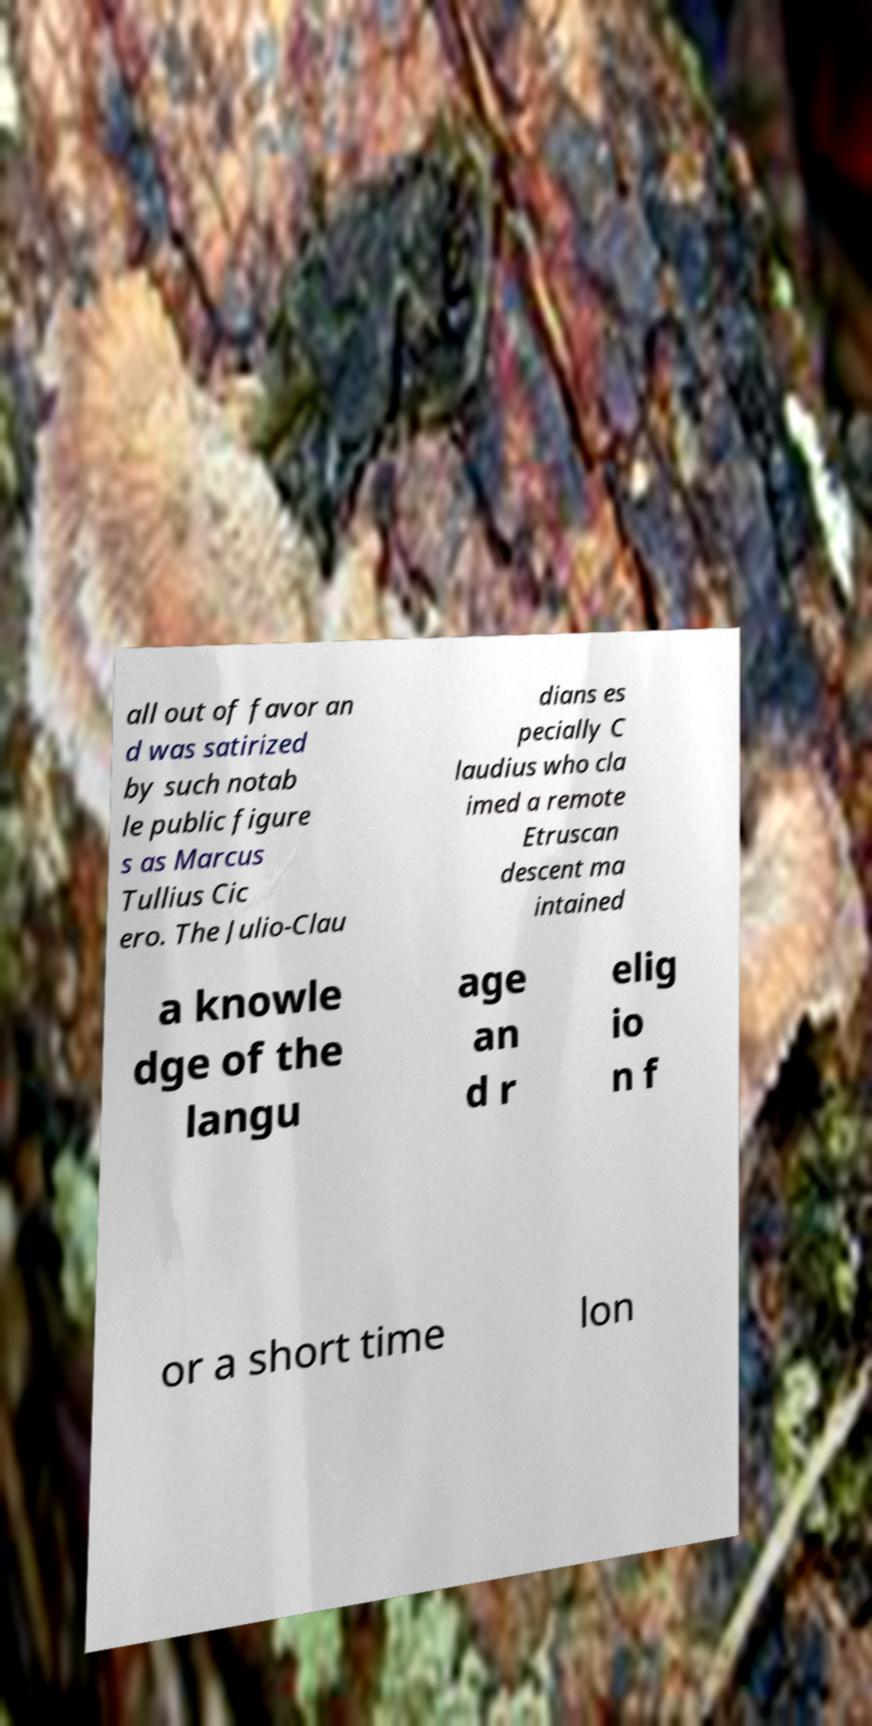Could you assist in decoding the text presented in this image and type it out clearly? all out of favor an d was satirized by such notab le public figure s as Marcus Tullius Cic ero. The Julio-Clau dians es pecially C laudius who cla imed a remote Etruscan descent ma intained a knowle dge of the langu age an d r elig io n f or a short time lon 